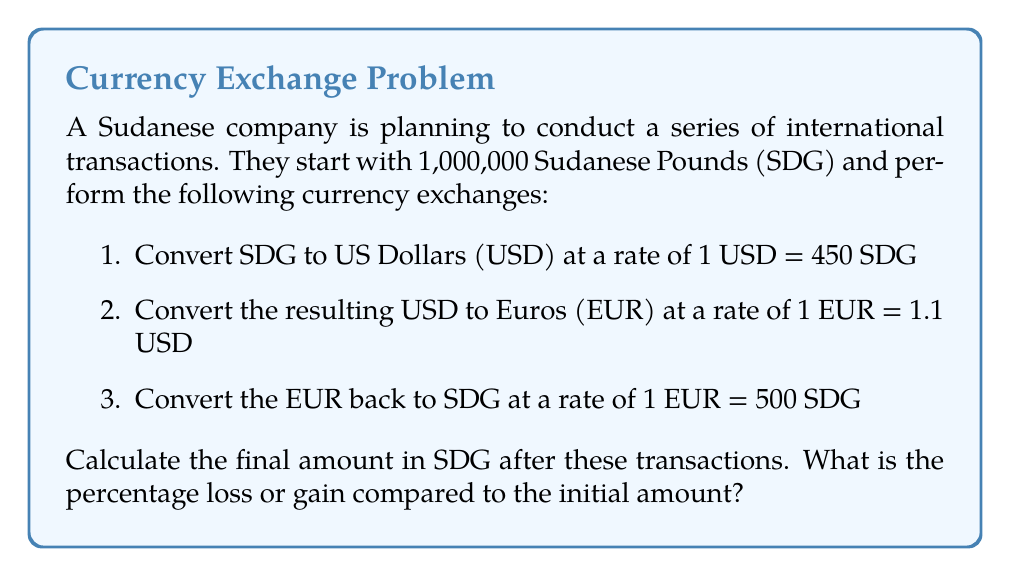Solve this math problem. Let's break this down step-by-step:

1. Convert SDG to USD:
   $$\frac{1,000,000 \text{ SDG}}{450 \text{ SDG/USD}} = 2,222.22 \text{ USD}$$

2. Convert USD to EUR:
   $$\frac{2,222.22 \text{ USD}}{1.1 \text{ USD/EUR}} = 2,020.20 \text{ EUR}$$

3. Convert EUR back to SDG:
   $$2,020.20 \text{ EUR} \times 500 \text{ SDG/EUR} = 1,010,100 \text{ SDG}$$

4. Calculate the difference:
   $$1,010,100 \text{ SDG} - 1,000,000 \text{ SDG} = 10,100 \text{ SDG}$$

5. Calculate the percentage change:
   $$\frac{10,100}{1,000,000} \times 100\% = 1.01\%$$

The final amount is 1,010,100 SDG, which is a gain of 10,100 SDG or 1.01% compared to the initial amount.
Answer: 1,010,100 SDG; 1.01% gain 